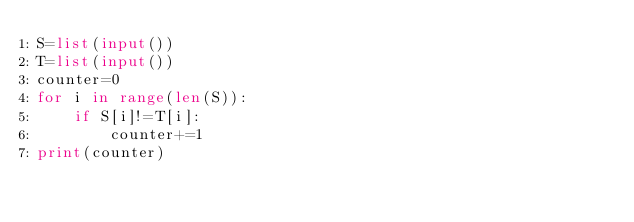<code> <loc_0><loc_0><loc_500><loc_500><_Python_>S=list(input())
T=list(input())
counter=0
for i in range(len(S)):
    if S[i]!=T[i]:
        counter+=1
print(counter)</code> 